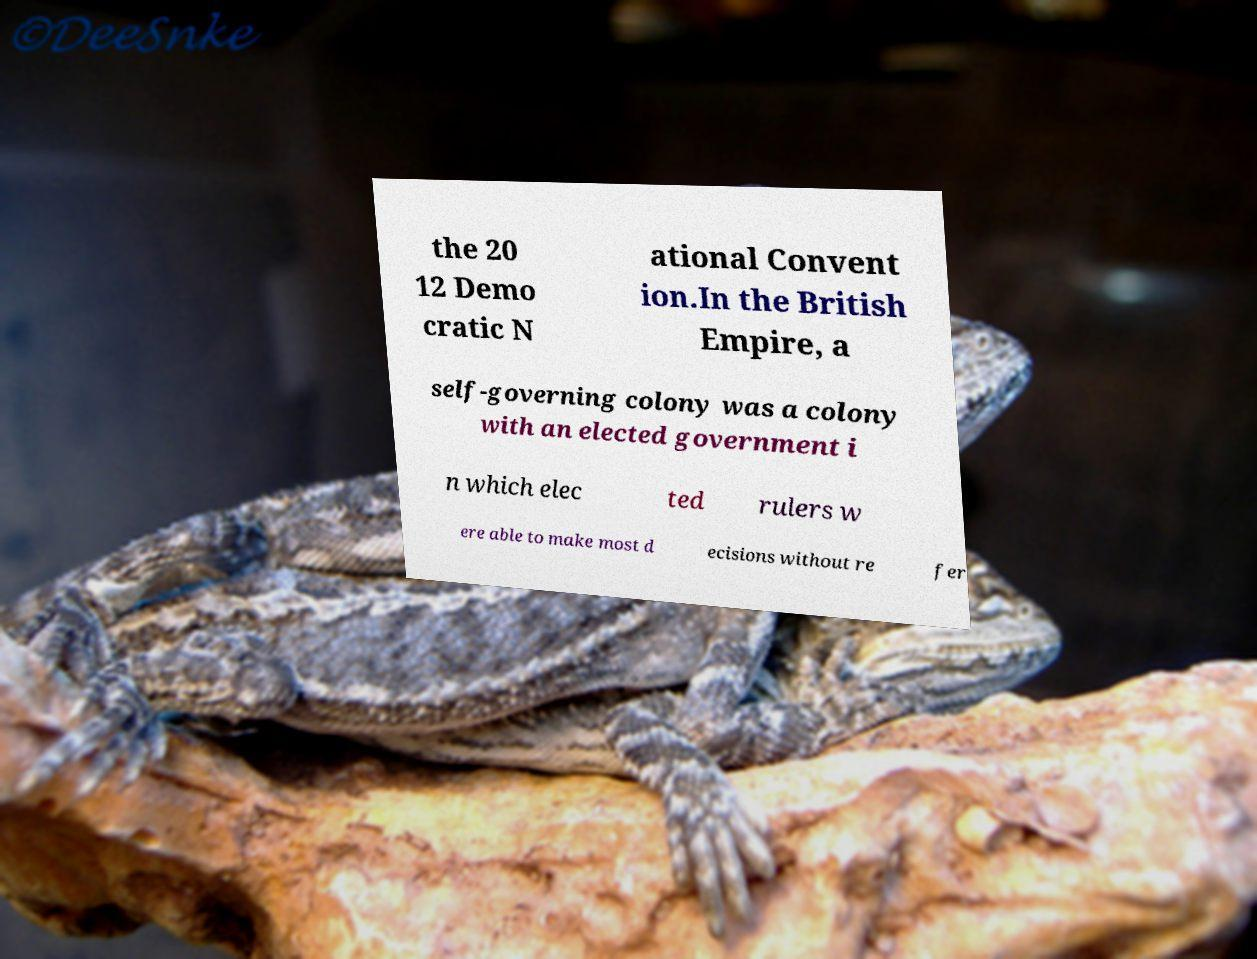What messages or text are displayed in this image? I need them in a readable, typed format. the 20 12 Demo cratic N ational Convent ion.In the British Empire, a self-governing colony was a colony with an elected government i n which elec ted rulers w ere able to make most d ecisions without re fer 